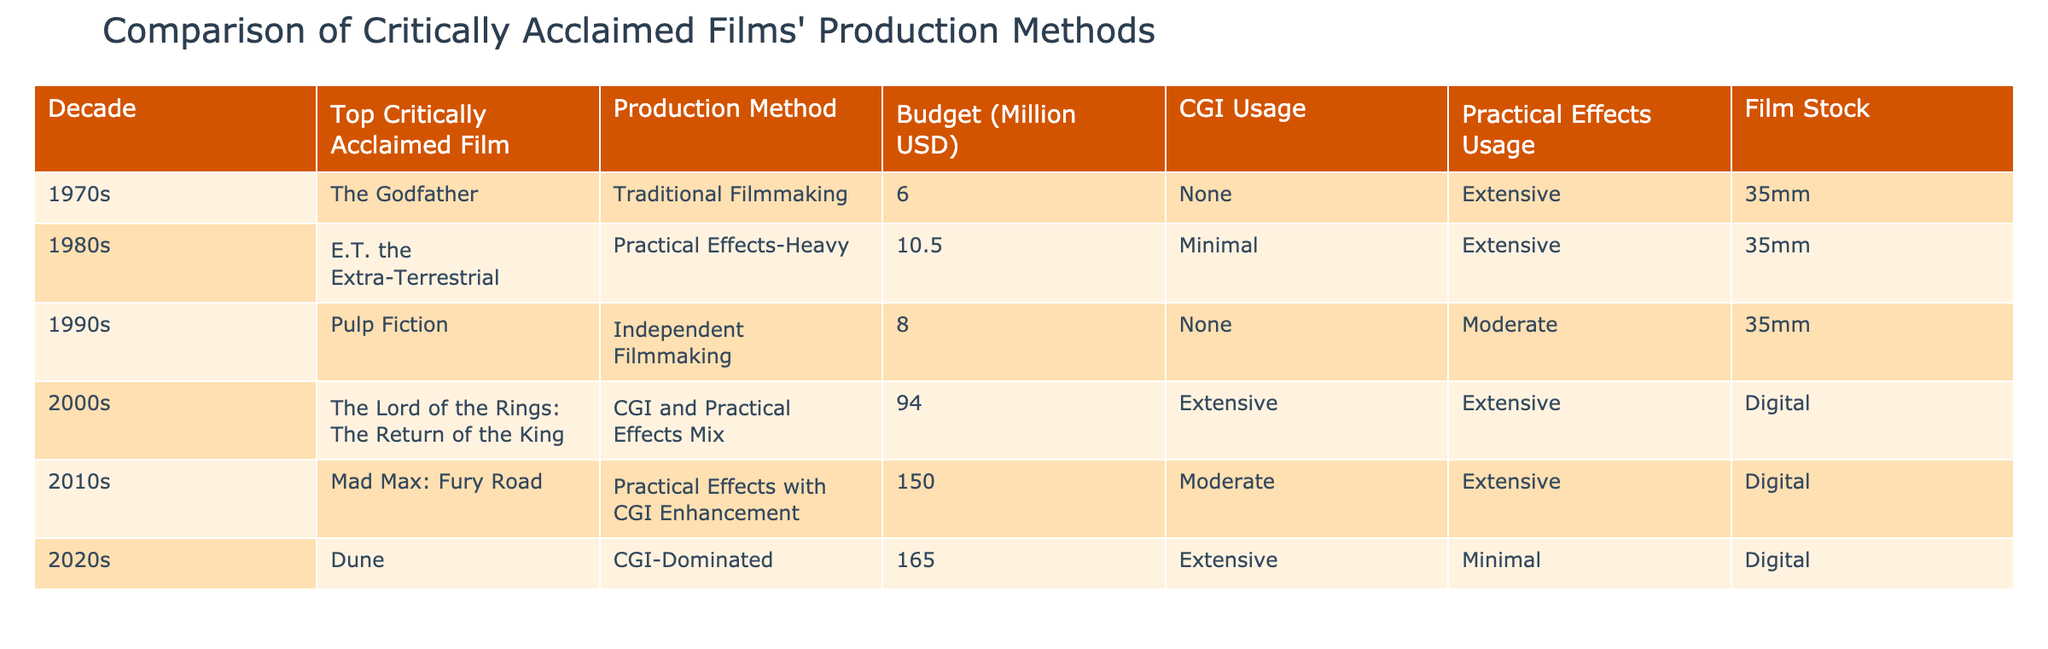What production method was used for "Dune"? Referring to the table, the production method listed for "Dune" is "CGI-Dominated".
Answer: CGI-Dominated Which film from the 1980s had a budget of 10.5 million USD? According to the table, "E.T. the Extra-Terrestrial" from the 1980s had a budget of 10.5 million USD.
Answer: E.T. the Extra-Terrestrial What is the average budget of the films in the 1990s? The budgets for the films from the 1990s were 8 million USD (Pulp Fiction). Since there is only one film listed, the average budget is simply 8 million USD.
Answer: 8 million USD Did any film from the 2000s use only practical effects? Looking at the table, the only film from the 2000s listed ("The Lord of the Rings: The Return of the King") used both CGI and practical effects, so the answer is no.
Answer: No Which decade had the highest average budget for its films? Adding up the budgets: 6 (1970s) + 10.5 (1980s) + 8 (1990s) + 94 (2000s) + 150 (2010s) + 165 (2020s) = 433 million USD. There are 6 films, so the average budget is 433/6 = approximately 72.17 million USD. The 2020s film "Dune" has the highest budget of 165 million USD; thus, the decade 2020s has the highest average per film based on what's present.
Answer: 2020s How many films used a combination of CGI and practical effects? Reviewing the table, "The Lord of the Rings: The Return of the King" and "Mad Max: Fury Road" both used a mix of CGI and practical effects. Thus, there are two films with this characteristic.
Answer: 2 